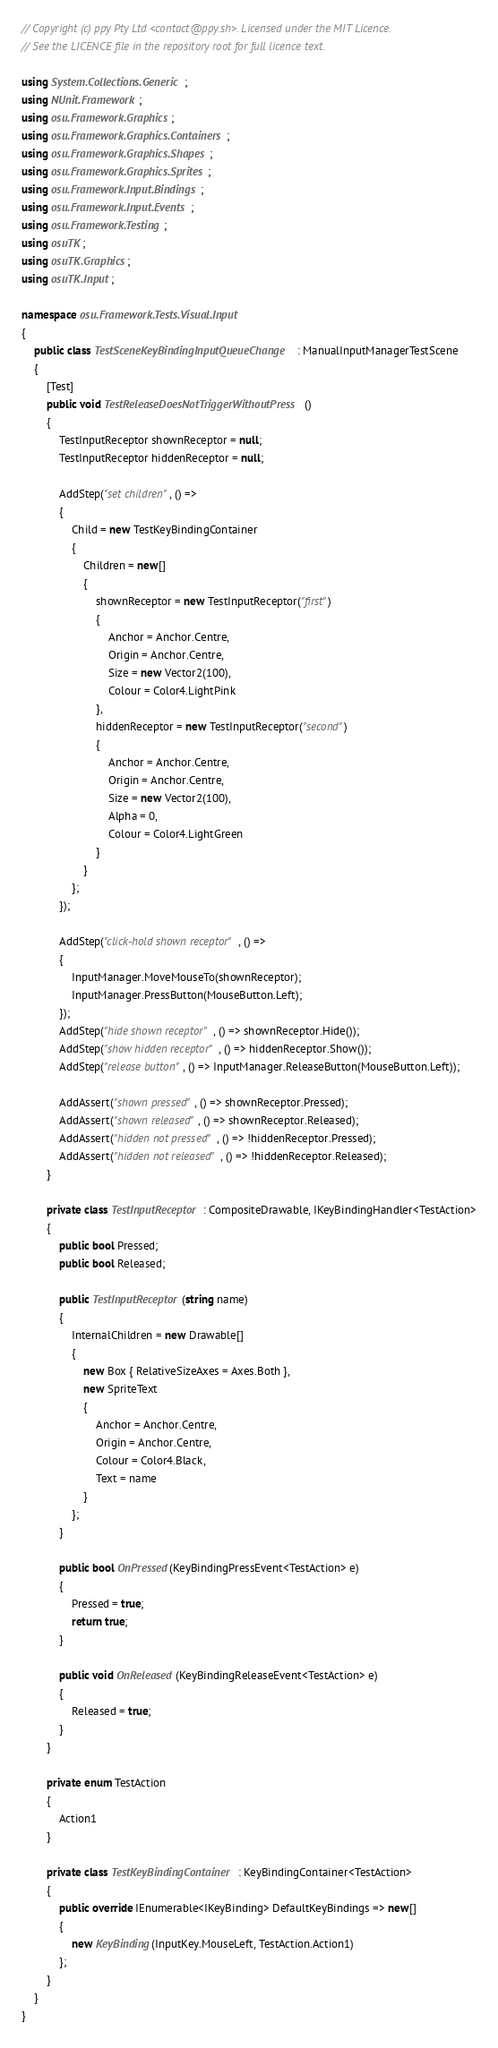<code> <loc_0><loc_0><loc_500><loc_500><_C#_>// Copyright (c) ppy Pty Ltd <contact@ppy.sh>. Licensed under the MIT Licence.
// See the LICENCE file in the repository root for full licence text.

using System.Collections.Generic;
using NUnit.Framework;
using osu.Framework.Graphics;
using osu.Framework.Graphics.Containers;
using osu.Framework.Graphics.Shapes;
using osu.Framework.Graphics.Sprites;
using osu.Framework.Input.Bindings;
using osu.Framework.Input.Events;
using osu.Framework.Testing;
using osuTK;
using osuTK.Graphics;
using osuTK.Input;

namespace osu.Framework.Tests.Visual.Input
{
    public class TestSceneKeyBindingInputQueueChange : ManualInputManagerTestScene
    {
        [Test]
        public void TestReleaseDoesNotTriggerWithoutPress()
        {
            TestInputReceptor shownReceptor = null;
            TestInputReceptor hiddenReceptor = null;

            AddStep("set children", () =>
            {
                Child = new TestKeyBindingContainer
                {
                    Children = new[]
                    {
                        shownReceptor = new TestInputReceptor("first")
                        {
                            Anchor = Anchor.Centre,
                            Origin = Anchor.Centre,
                            Size = new Vector2(100),
                            Colour = Color4.LightPink
                        },
                        hiddenReceptor = new TestInputReceptor("second")
                        {
                            Anchor = Anchor.Centre,
                            Origin = Anchor.Centre,
                            Size = new Vector2(100),
                            Alpha = 0,
                            Colour = Color4.LightGreen
                        }
                    }
                };
            });

            AddStep("click-hold shown receptor", () =>
            {
                InputManager.MoveMouseTo(shownReceptor);
                InputManager.PressButton(MouseButton.Left);
            });
            AddStep("hide shown receptor", () => shownReceptor.Hide());
            AddStep("show hidden receptor", () => hiddenReceptor.Show());
            AddStep("release button", () => InputManager.ReleaseButton(MouseButton.Left));

            AddAssert("shown pressed", () => shownReceptor.Pressed);
            AddAssert("shown released", () => shownReceptor.Released);
            AddAssert("hidden not pressed", () => !hiddenReceptor.Pressed);
            AddAssert("hidden not released", () => !hiddenReceptor.Released);
        }

        private class TestInputReceptor : CompositeDrawable, IKeyBindingHandler<TestAction>
        {
            public bool Pressed;
            public bool Released;

            public TestInputReceptor(string name)
            {
                InternalChildren = new Drawable[]
                {
                    new Box { RelativeSizeAxes = Axes.Both },
                    new SpriteText
                    {
                        Anchor = Anchor.Centre,
                        Origin = Anchor.Centre,
                        Colour = Color4.Black,
                        Text = name
                    }
                };
            }

            public bool OnPressed(KeyBindingPressEvent<TestAction> e)
            {
                Pressed = true;
                return true;
            }

            public void OnReleased(KeyBindingReleaseEvent<TestAction> e)
            {
                Released = true;
            }
        }

        private enum TestAction
        {
            Action1
        }

        private class TestKeyBindingContainer : KeyBindingContainer<TestAction>
        {
            public override IEnumerable<IKeyBinding> DefaultKeyBindings => new[]
            {
                new KeyBinding(InputKey.MouseLeft, TestAction.Action1)
            };
        }
    }
}
</code> 